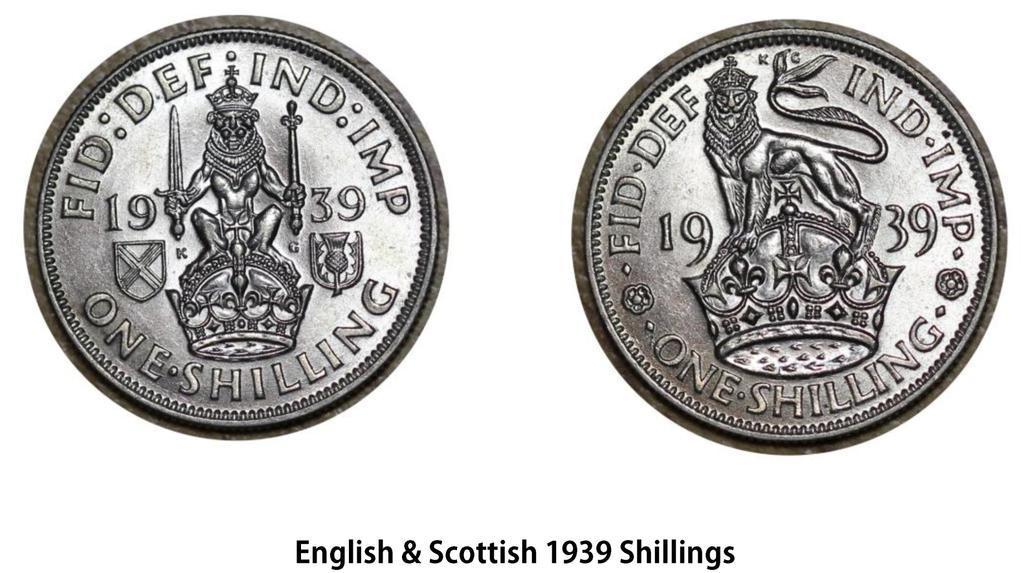<image>
Relay a brief, clear account of the picture shown. English and Scottish shillings from 1939 both feature crowns on them. 